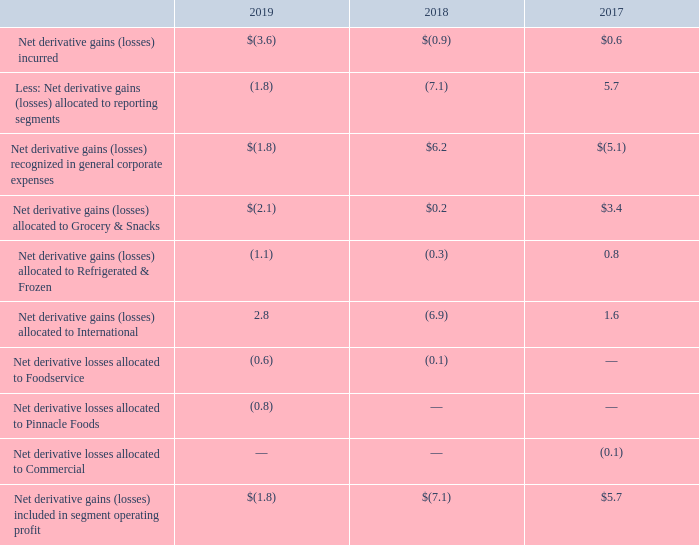Presentation of Derivative Gains (Losses) for Economic Hedges of Forecasted Cash Flows in Segment Results
Derivatives used to manage commodity price risk and foreign currency risk are not designated for hedge accounting treatment. We believe these derivatives provide economic hedges of certain forecasted transactions. As such, these derivatives are recognized at fair market value with realized and unrealized gains and losses recognized in general corporate expenses. The gains and losses are subsequently recognized in the operating results of the reporting segments in the period in which the underlying transaction being economically hedged is included in earnings. In the event that management determines a particular derivative entered into as an economic hedge of a forecasted commodity purchase has ceased to function as an economic hedge, we cease recognizing further gains and losses on such derivatives in corporate expense and begin recognizing such gains and losses within segment operating results, immediately.
The following table presents the net derivative gains (losses) from economic hedges of forecasted commodity consumption and the foreign currency risk of certain forecasted transactions, under this methodology:
As of May 26, 2019, the cumulative amount of net derivative gains from economic hedges that had been recognized in general corporate expenses and not yet allocated to reporting segments was $1.4 million. This amount reflected net gains of $1.0 million incurred during the fiscal year ended May 26, 2019, as well as net gains of $0.4 million incurred prior to fiscal 2019. Based on our forecasts of the timing of recognition of the underlying hedged items, we expect to reclassify to segment operating results gains of $0.9 million in fiscal 2020 and $0.5 million in fiscal 2021 and thereafter.
Notes to Consolidated Financial Statements - (Continued) Fiscal Years Ended May 26, 2019, May 27, 2018, and May 28, 2017 (columnar dollars in millions except per share amounts)
What is the use of derivatives? Manage commodity price risk. What does the table show us? The net derivative gains (losses) from economic hedges of forecasted commodity consumption and the foreign currency risk of certain forecasted transactions. What were the net derivative losses allocated to Foodservice in 2018 and 2019, respectively?
Answer scale should be: million. (0.6), (0.1). What is the percentage change in net derivative gains (losses) included in segment operating profit in 2019 compared to 2017?
Answer scale should be: percent. (-1.8-5.7)/5.7 
Answer: -131.58. What is the average net derivative gains (losses) allocated to Grocery & Snacks from 2017 to 2019?
Answer scale should be: million. (-2.1+0.2+3.4)/3 
Answer: 0.5. What are the total net derivative losses allocated to Foodservice, Pinnacle Foods, as well as Commercial in 2019?
Answer scale should be: million. (-0.6)+(-0.8) 
Answer: -1.4. 